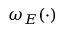Convert formula to latex. <formula><loc_0><loc_0><loc_500><loc_500>\omega _ { E } ( \cdot )</formula> 